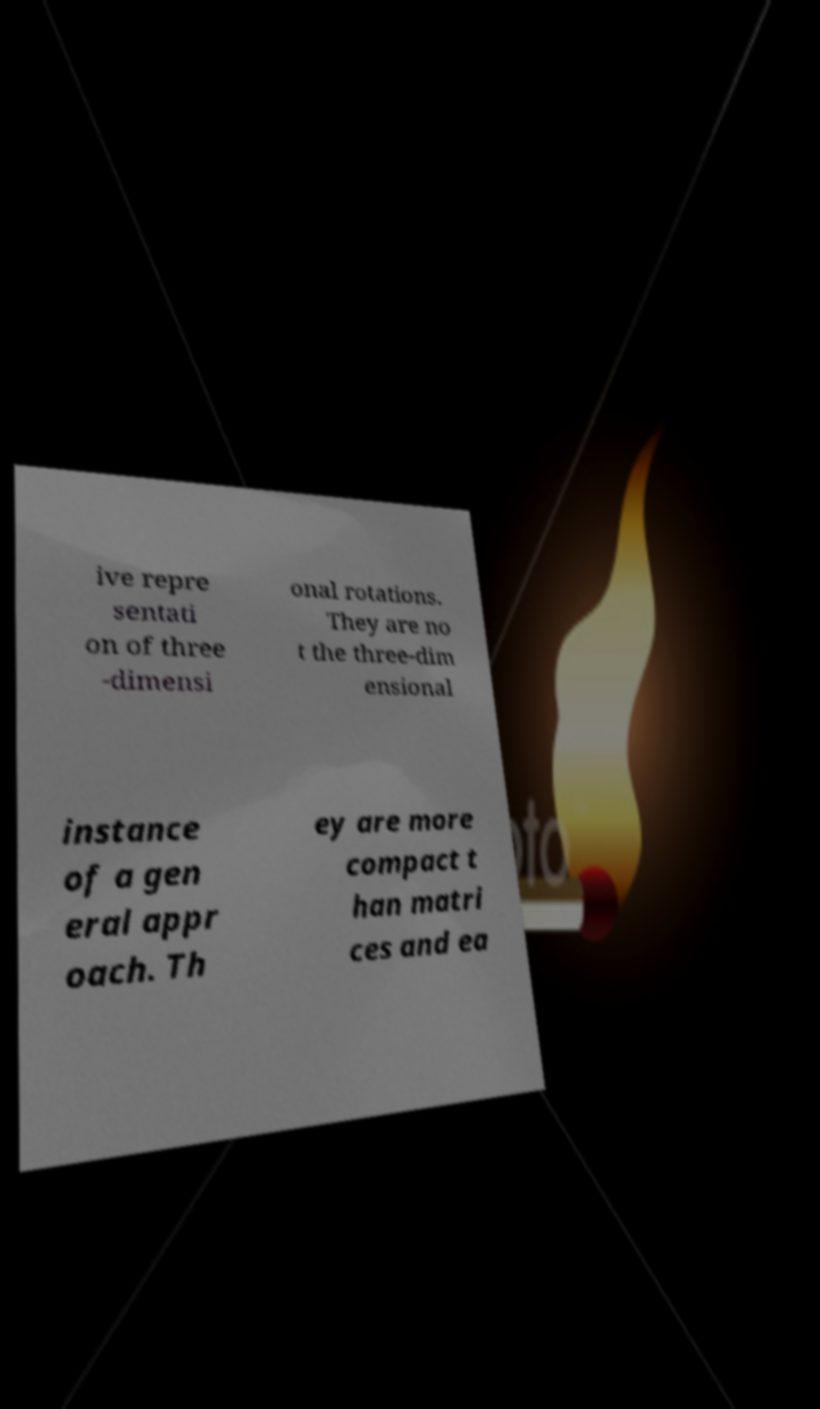Can you read and provide the text displayed in the image?This photo seems to have some interesting text. Can you extract and type it out for me? ive repre sentati on of three -dimensi onal rotations. They are no t the three-dim ensional instance of a gen eral appr oach. Th ey are more compact t han matri ces and ea 